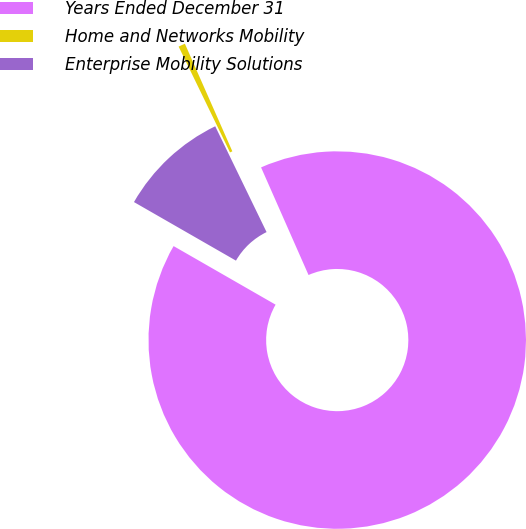<chart> <loc_0><loc_0><loc_500><loc_500><pie_chart><fcel>Years Ended December 31<fcel>Home and Networks Mobility<fcel>Enterprise Mobility Solutions<nl><fcel>89.9%<fcel>0.58%<fcel>9.51%<nl></chart> 